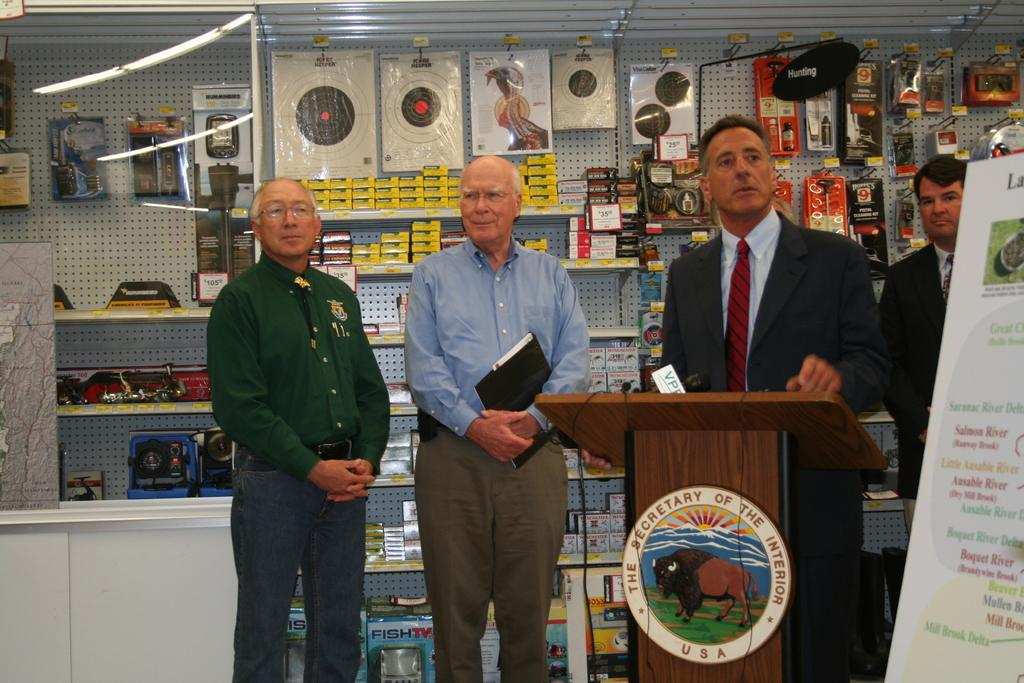How many men are in the image? There are four men standing in the image. What can be seen on the podium in the image? There is a microphone on the podium in the image. What is hanging on the wall in the image? There is a poster in the image. What type of items can be seen in the background of the image? In the background, there are packets and boxes visible, along with other objects. How many dogs are sitting on the podium in the image? There are no dogs present in the image; only the men, podium, microphone, poster, and background items can be seen. 